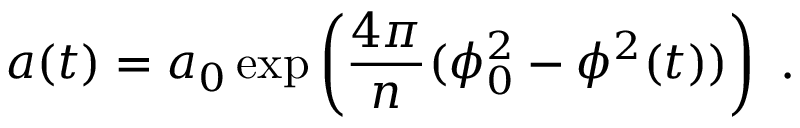<formula> <loc_0><loc_0><loc_500><loc_500>a ( t ) = a _ { 0 } \exp \left ( { \frac { 4 \pi } { n } } ( \phi _ { 0 } ^ { 2 } - \phi ^ { 2 } ( t ) ) \right ) \ .</formula> 